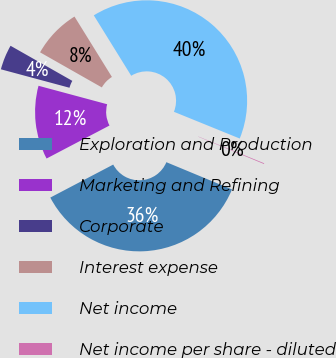Convert chart to OTSL. <chart><loc_0><loc_0><loc_500><loc_500><pie_chart><fcel>Exploration and Production<fcel>Marketing and Refining<fcel>Corporate<fcel>Interest expense<fcel>Net income<fcel>Net income per share - diluted<nl><fcel>36.05%<fcel>11.87%<fcel>4.04%<fcel>7.95%<fcel>39.97%<fcel>0.12%<nl></chart> 